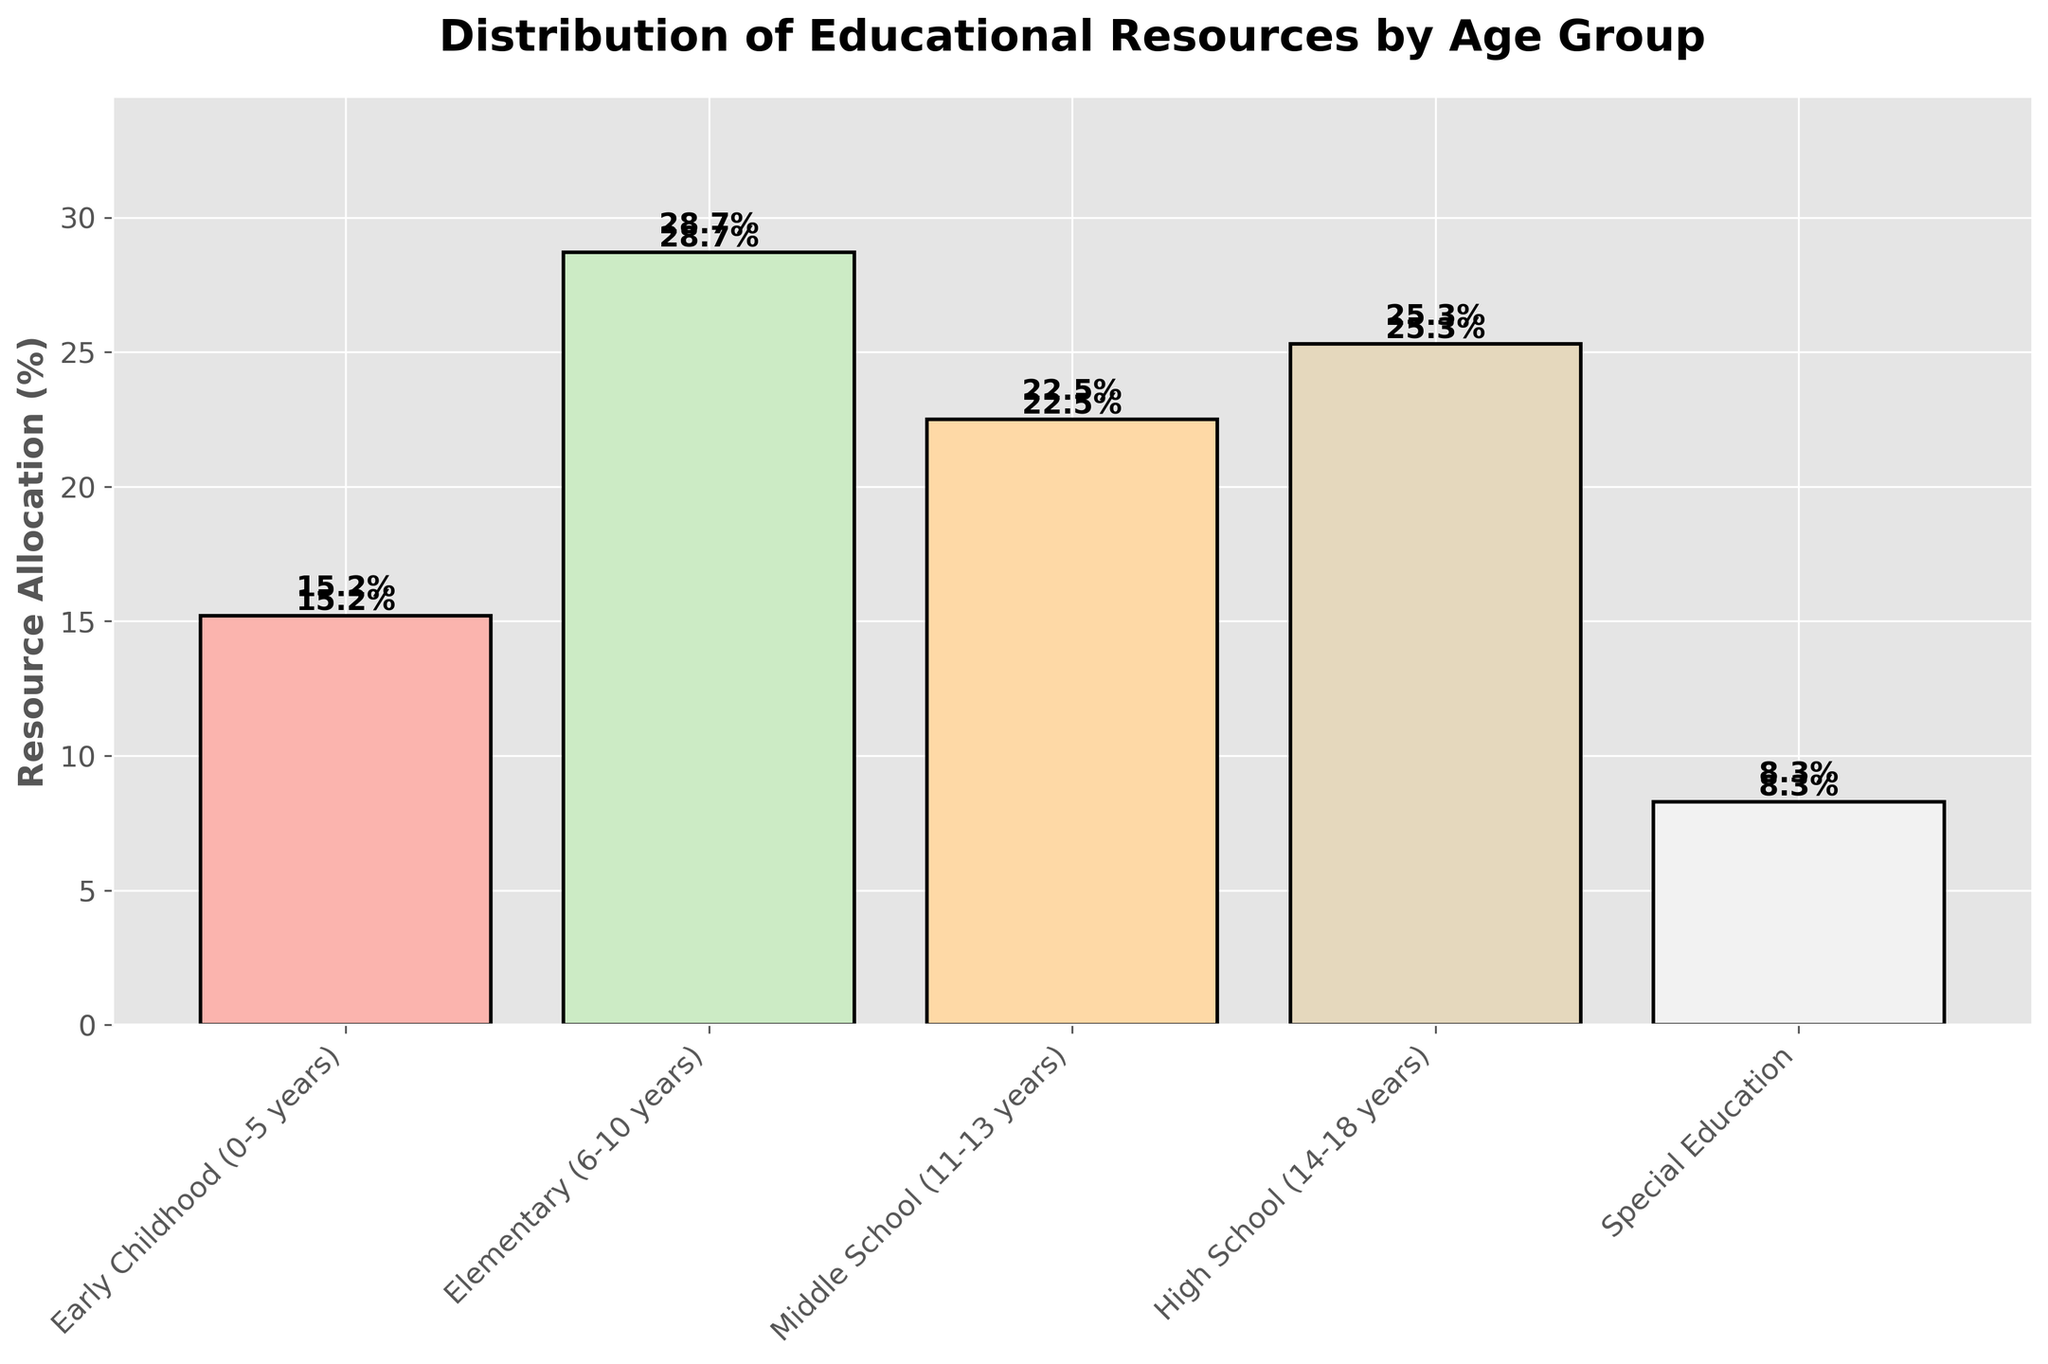What's the total percentage of resources allocated to Elementary and Middle School together? To find the total, sum the resource allocations for Elementary and Middle School: 28.7% (Elementary) + 22.5% (Middle School) = 51.2%.
Answer: 51.2% Which age group receives the highest percentage of resources? Identify the age group with the tallest bar. The Elementary (6-10 years) group has the tallest bar at 28.7%.
Answer: Elementary (6-10 years) Compare the resource allocation for Early Childhood and High School. Which one is higher and by how much? High School allocation is 25.3%, while Early Childhood allocation is 15.2%. Subtract Early Childhood from High School: 25.3% - 15.2% = 10.1%.
Answer: High School by 10.1% What's the difference in resource allocation between the least and most funded groups? The least funded group is Special Education at 8.3%, and the most funded is Elementary at 28.7%. Subtract the least from the most: 28.7% - 8.3% = 20.4%.
Answer: 20.4% Is the resource allocation for High School greater than the combined allocations of Early Childhood and Special Education? Calculate the combined allocation for Early Childhood and Special Education: 15.2% + 8.3% = 23.5%. Compare it with High School's 25.3%, which is higher.
Answer: Yes Which two age groups have the closest percentages in resource allocation, and what is the difference between them? Compare the differences between each pair of adjacent bars: Middle School (22.5%) and High School (25.3%) have the closest at 2.8%.
Answer: Middle School and High School, 2.8% What is the average percentage of resources allocated across all groups? Sum the percentages and divide by the number of groups: (15.2 + 28.7 + 22.5 + 25.3 + 8.3) / 5 = 20%.
Answer: 20% Between which age groups is there the largest jump in resource allocation? Compare the differences: Early Childhood to Elementary (13.5%), Elementary to Middle School (6.2%), Middle School to High School (2.8%), High School to Special Education (17%). The largest jump is from High School to Special Education.
Answer: Early Childhood to Elementary (13.5%) 